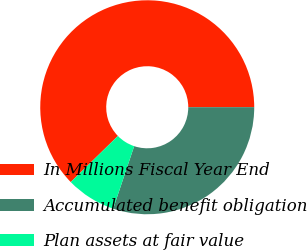Convert chart to OTSL. <chart><loc_0><loc_0><loc_500><loc_500><pie_chart><fcel>In Millions Fiscal Year End<fcel>Accumulated benefit obligation<fcel>Plan assets at fair value<nl><fcel>62.31%<fcel>30.17%<fcel>7.52%<nl></chart> 